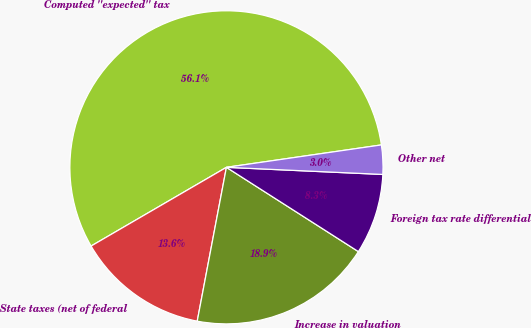Convert chart. <chart><loc_0><loc_0><loc_500><loc_500><pie_chart><fcel>Computed ''expected'' tax<fcel>State taxes (net of federal<fcel>Increase in valuation<fcel>Foreign tax rate differential<fcel>Other net<nl><fcel>56.1%<fcel>13.63%<fcel>18.94%<fcel>8.32%<fcel>3.01%<nl></chart> 